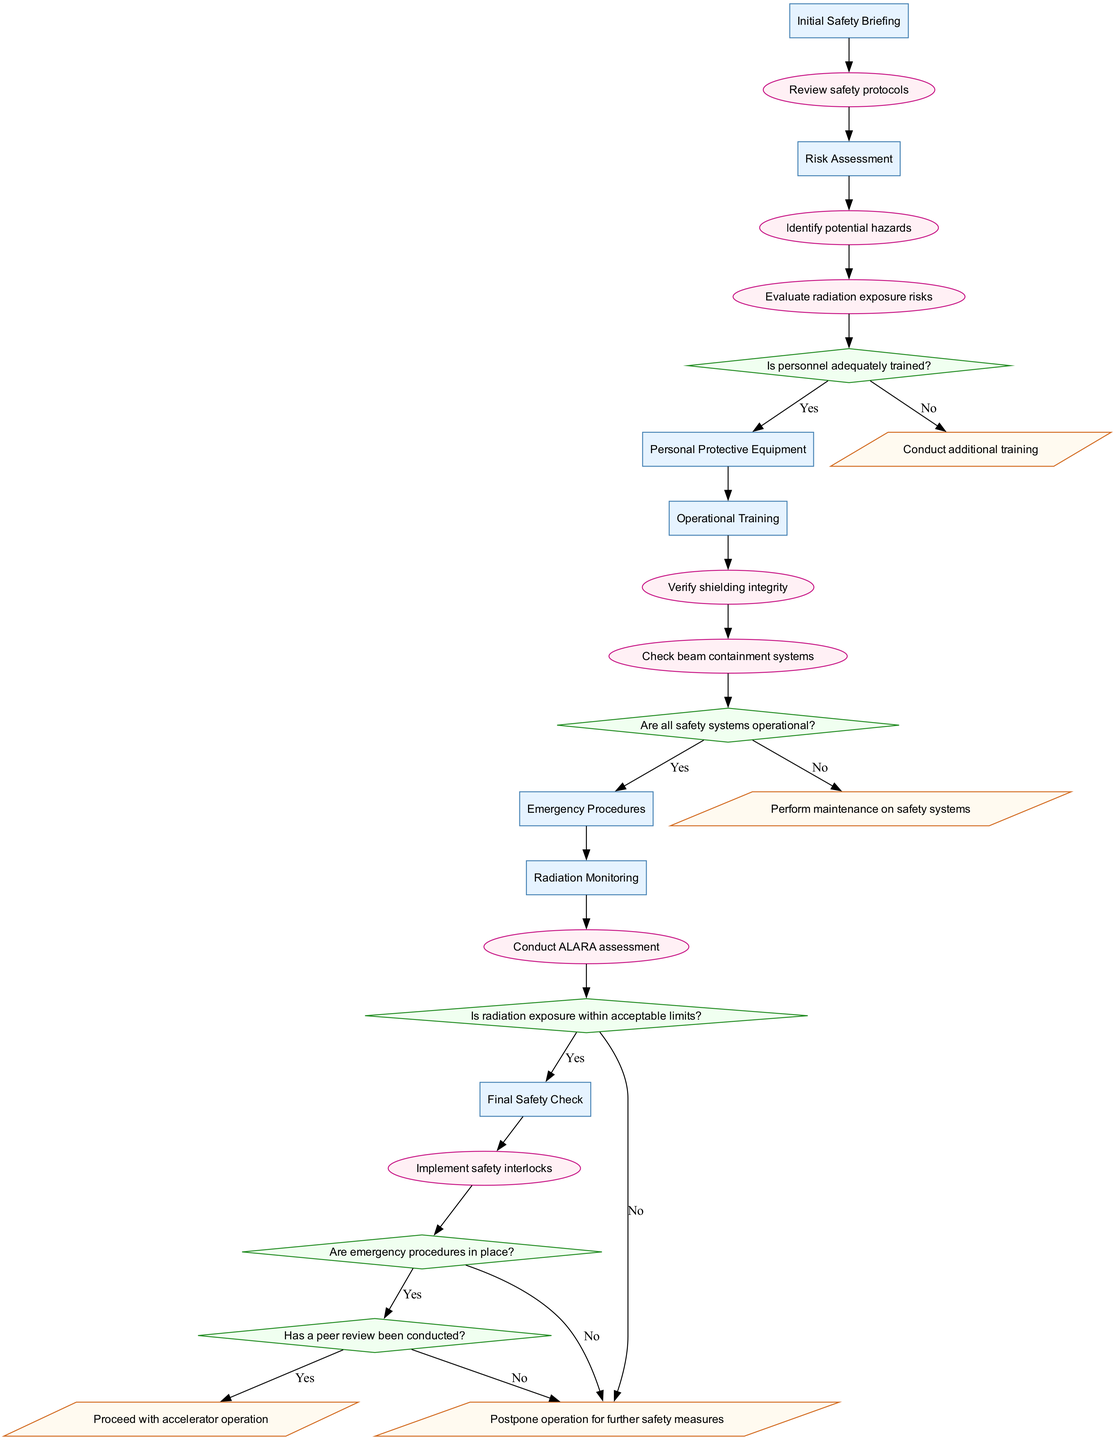What is the first stage in the safety procedures? The diagram lists stages in a top-down manner, and the first stage is labeled as "Initial Safety Briefing."
Answer: Initial Safety Briefing How many actions are outlined in the procedure? By counting the actions in the diagram, there are a total of 7 actions listed.
Answer: 7 What decision follows the "Evaluate radiation exposure risks" action? The action "Evaluate radiation exposure risks" leads directly to the decision node, which asks, "Is radiation exposure within acceptable limits?"
Answer: Is radiation exposure within acceptable limits? What is the outcome if all safety systems are not operational? Following the decision "Are all safety systems operational?" with a "No" response leads to the outcome, "Perform maintenance on safety systems."
Answer: Perform maintenance on safety systems If personnel are adequately trained, what is the next stage? If the decision "Is personnel adequately trained?" responds "Yes", the flow moves to the next stage, which is "Personal Protective Equipment."
Answer: Personal Protective Equipment What are the last two actions before reaching a decision? Reviewing the diagram, the last two actions before a decision are "Implement safety interlocks" and "Final Safety Check."
Answer: Implement safety interlocks and Final Safety Check What happens if radiation exposure is not within acceptable limits? In that case, the outcome reads "Postpone operation for further safety measures."
Answer: Postpone operation for further safety measures How are emergency procedures evaluated in this pathway? The pathway examines emergency procedures through the decision "Are emergency procedures in place?", which directly influences subsequent outcomes.
Answer: Are emergency procedures in place? What signifies successful completion of the clinical pathway? The successful completion is marked by the outcome "Proceed with accelerator operation," which indicates readiness for operation after passing all safety checks.
Answer: Proceed with accelerator operation 